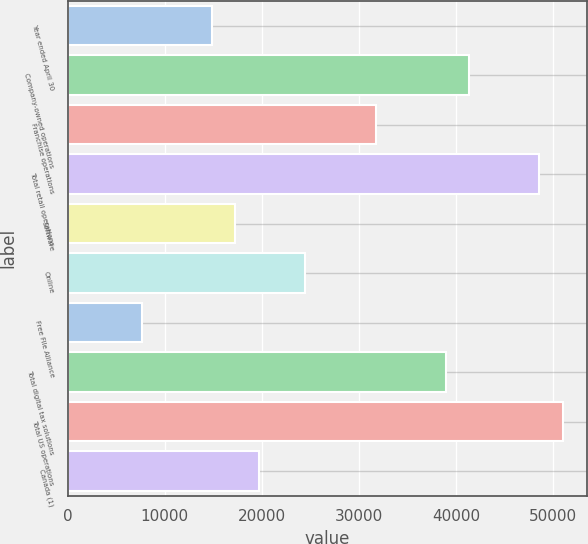<chart> <loc_0><loc_0><loc_500><loc_500><bar_chart><fcel>Year ended April 30<fcel>Company-owned operations<fcel>Franchise operations<fcel>Total retail operations<fcel>Software<fcel>Online<fcel>Free File Alliance<fcel>Total digital tax solutions<fcel>Total US operations<fcel>Canada (1)<nl><fcel>14859.4<fcel>41373.8<fcel>31732.2<fcel>48605<fcel>17269.8<fcel>24501<fcel>7628.2<fcel>38963.4<fcel>51015.4<fcel>19680.2<nl></chart> 